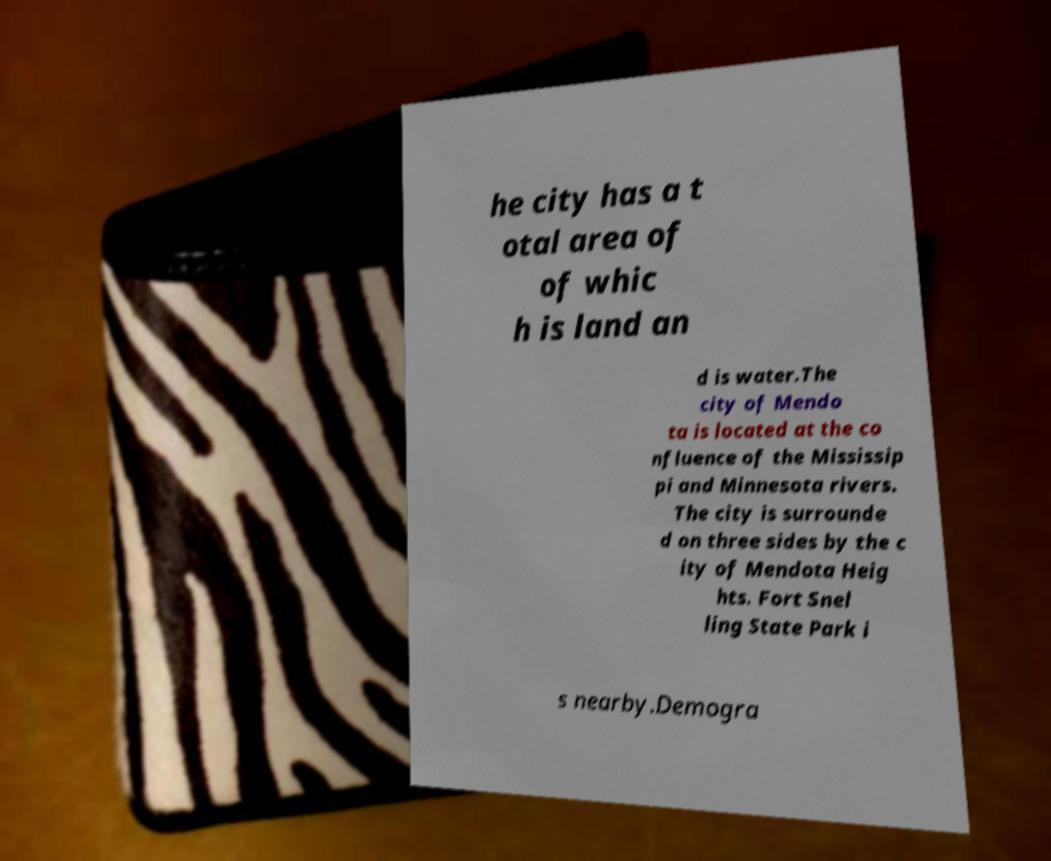Could you extract and type out the text from this image? he city has a t otal area of of whic h is land an d is water.The city of Mendo ta is located at the co nfluence of the Mississip pi and Minnesota rivers. The city is surrounde d on three sides by the c ity of Mendota Heig hts. Fort Snel ling State Park i s nearby.Demogra 